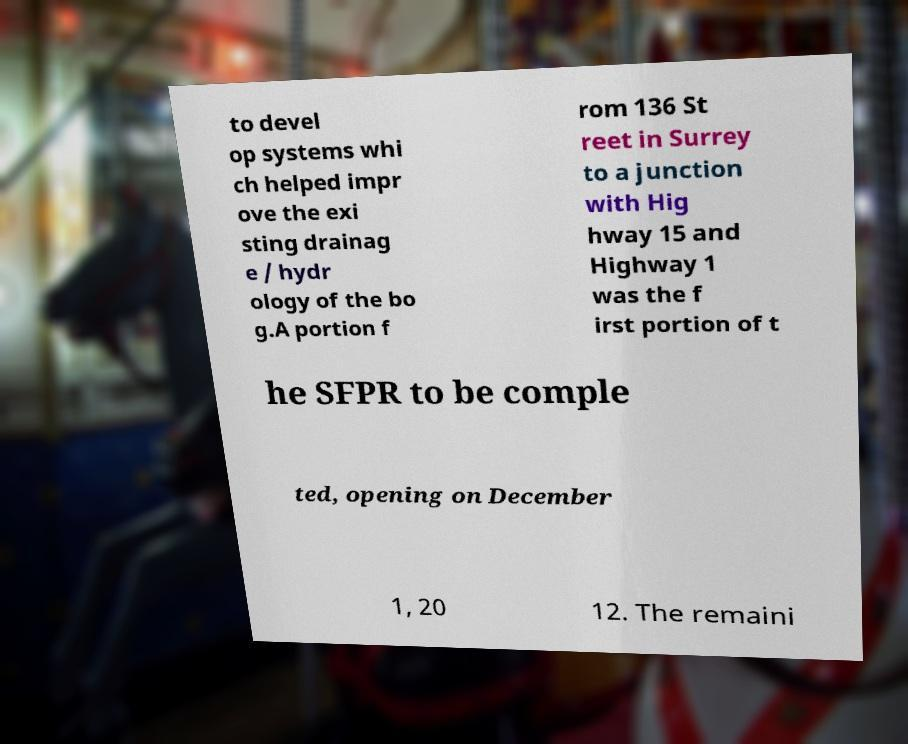Could you extract and type out the text from this image? to devel op systems whi ch helped impr ove the exi sting drainag e / hydr ology of the bo g.A portion f rom 136 St reet in Surrey to a junction with Hig hway 15 and Highway 1 was the f irst portion of t he SFPR to be comple ted, opening on December 1, 20 12. The remaini 